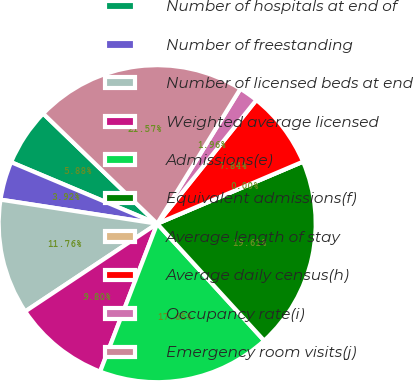Convert chart to OTSL. <chart><loc_0><loc_0><loc_500><loc_500><pie_chart><fcel>Number of hospitals at end of<fcel>Number of freestanding<fcel>Number of licensed beds at end<fcel>Weighted average licensed<fcel>Admissions(e)<fcel>Equivalent admissions(f)<fcel>Average length of stay<fcel>Average daily census(h)<fcel>Occupancy rate(i)<fcel>Emergency room visits(j)<nl><fcel>5.88%<fcel>3.92%<fcel>11.76%<fcel>9.8%<fcel>17.65%<fcel>19.61%<fcel>0.0%<fcel>7.84%<fcel>1.96%<fcel>21.57%<nl></chart> 